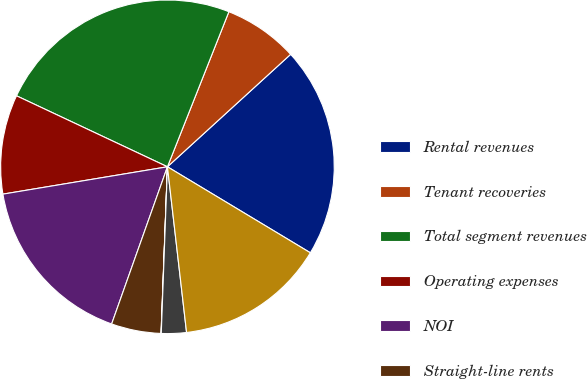Convert chart to OTSL. <chart><loc_0><loc_0><loc_500><loc_500><pie_chart><fcel>Rental revenues<fcel>Tenant recoveries<fcel>Total segment revenues<fcel>Operating expenses<fcel>NOI<fcel>Straight-line rents<fcel>Amortization of market lease<fcel>Lease termination fees<fcel>Adjusted NOI<nl><fcel>20.4%<fcel>7.22%<fcel>24.01%<fcel>9.62%<fcel>16.95%<fcel>4.82%<fcel>0.02%<fcel>2.42%<fcel>14.55%<nl></chart> 